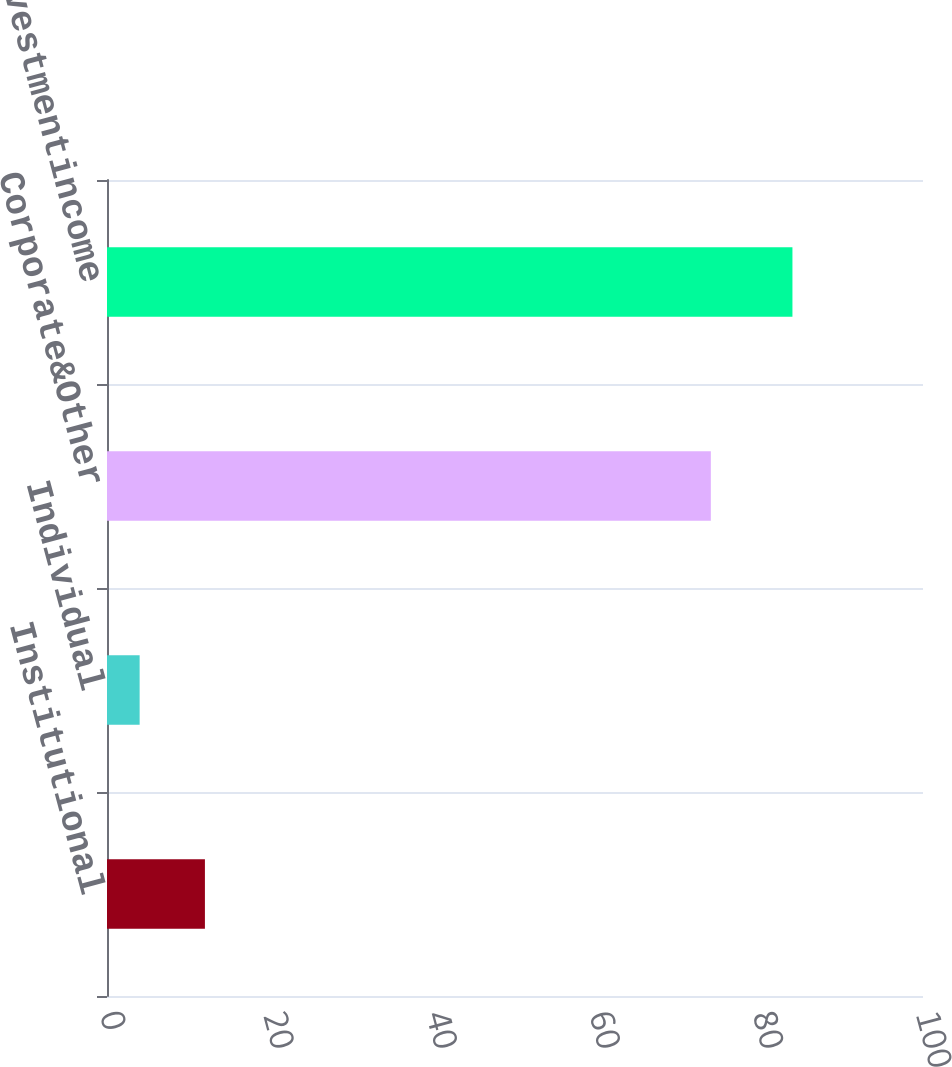<chart> <loc_0><loc_0><loc_500><loc_500><bar_chart><fcel>Institutional<fcel>Individual<fcel>Corporate&Other<fcel>Totalnetinvestmentincome<nl><fcel>12<fcel>4<fcel>74<fcel>84<nl></chart> 